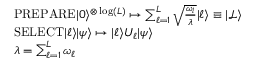<formula> <loc_0><loc_0><loc_500><loc_500>\begin{array} { r l } & { P R E P A R E | 0 \rangle ^ { \otimes \log ( L ) } \mapsto \sum _ { \ell = 1 } ^ { L } \sqrt { \frac { \omega _ { l } } { \lambda } } | \ell \rangle \equiv | \mathcal { L } \rangle } \\ & { S E L E C T | \ell \rangle | \psi \rangle \mapsto | \ell \rangle U _ { \ell } | \psi \rangle } \\ & { \lambda = \sum _ { \ell = 1 } ^ { L } \omega _ { \ell } } \end{array}</formula> 